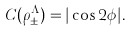Convert formula to latex. <formula><loc_0><loc_0><loc_500><loc_500>C ( \rho _ { \pm } ^ { \Lambda } ) = | \cos 2 \phi | .</formula> 